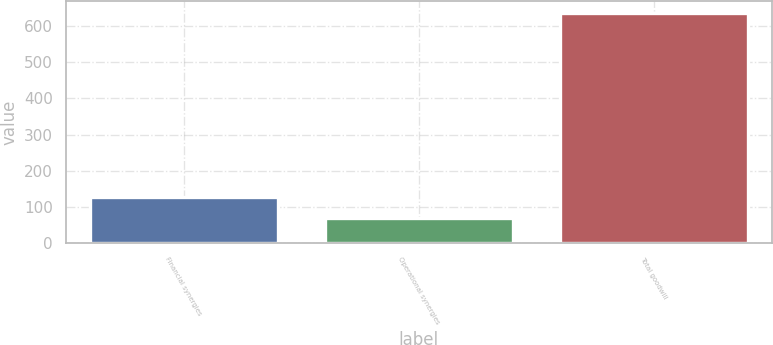<chart> <loc_0><loc_0><loc_500><loc_500><bar_chart><fcel>Financial synergies<fcel>Operational synergies<fcel>Total goodwill<nl><fcel>126.7<fcel>70<fcel>637<nl></chart> 